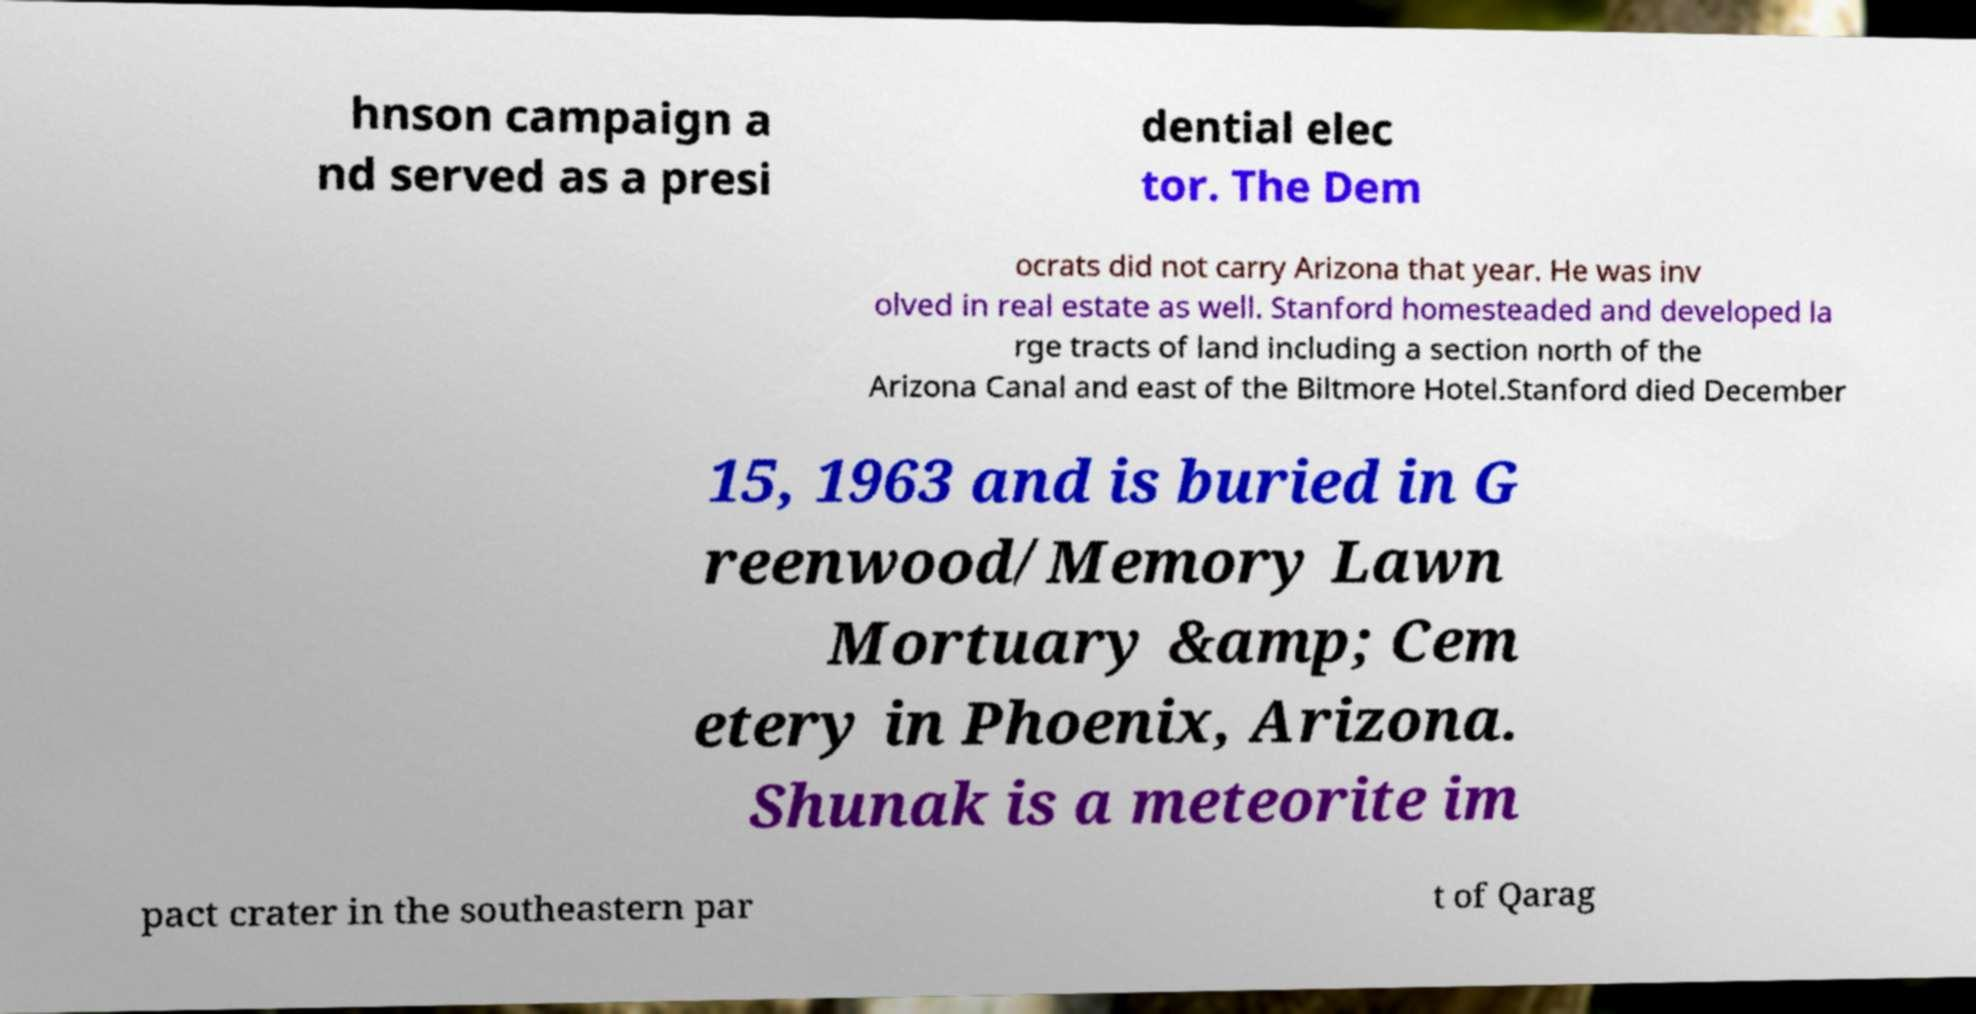Can you read and provide the text displayed in the image?This photo seems to have some interesting text. Can you extract and type it out for me? hnson campaign a nd served as a presi dential elec tor. The Dem ocrats did not carry Arizona that year. He was inv olved in real estate as well. Stanford homesteaded and developed la rge tracts of land including a section north of the Arizona Canal and east of the Biltmore Hotel.Stanford died December 15, 1963 and is buried in G reenwood/Memory Lawn Mortuary &amp; Cem etery in Phoenix, Arizona. Shunak is a meteorite im pact crater in the southeastern par t of Qarag 